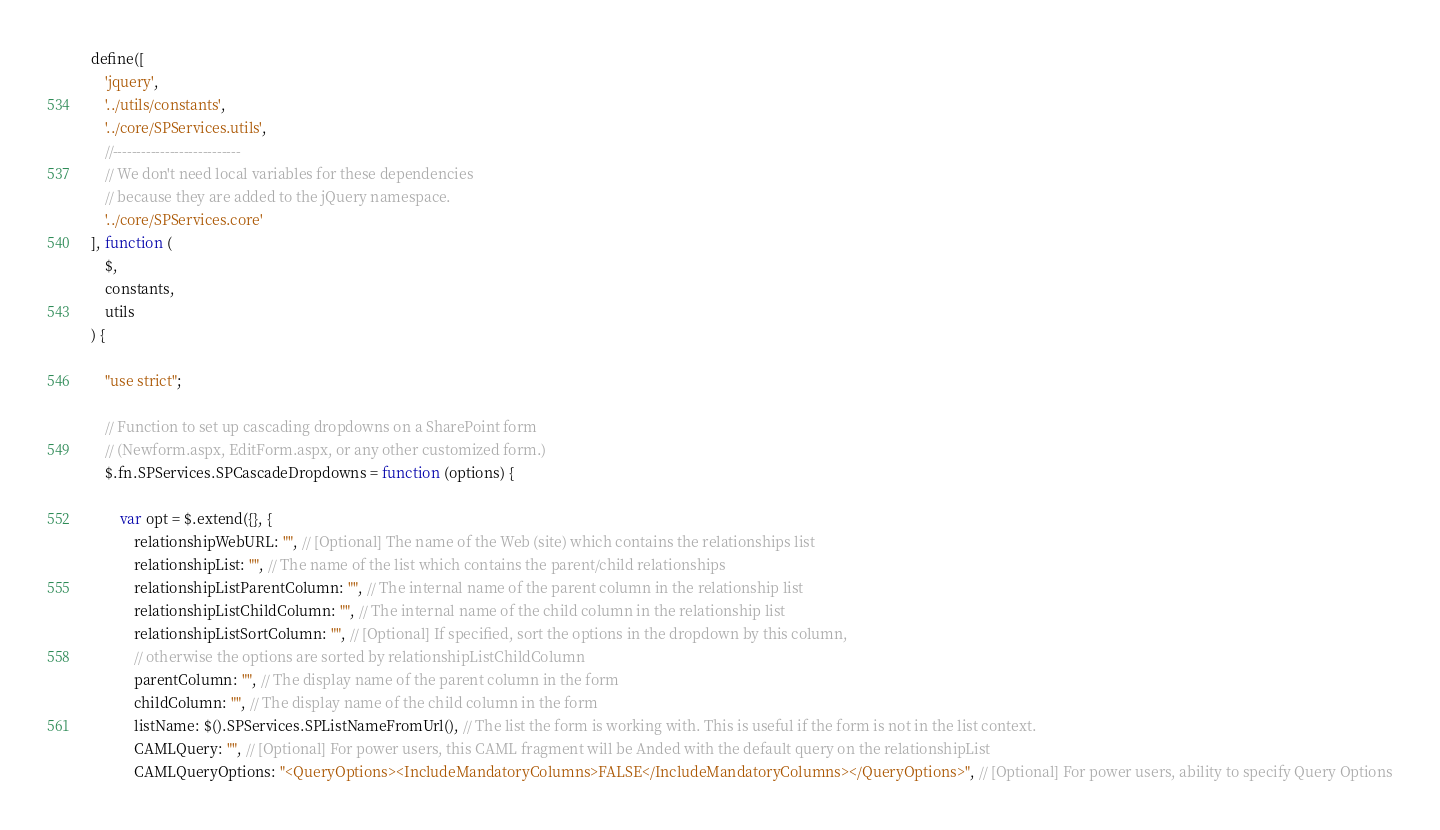<code> <loc_0><loc_0><loc_500><loc_500><_JavaScript_>define([
    'jquery',
    '../utils/constants',
    '../core/SPServices.utils',
    //---------------------------
    // We don't need local variables for these dependencies
    // because they are added to the jQuery namespace.
    '../core/SPServices.core'
], function (
    $,
    constants,
    utils
) {

    "use strict";

    // Function to set up cascading dropdowns on a SharePoint form
    // (Newform.aspx, EditForm.aspx, or any other customized form.)
    $.fn.SPServices.SPCascadeDropdowns = function (options) {

        var opt = $.extend({}, {
            relationshipWebURL: "", // [Optional] The name of the Web (site) which contains the relationships list
            relationshipList: "", // The name of the list which contains the parent/child relationships
            relationshipListParentColumn: "", // The internal name of the parent column in the relationship list
            relationshipListChildColumn: "", // The internal name of the child column in the relationship list
            relationshipListSortColumn: "", // [Optional] If specified, sort the options in the dropdown by this column,
            // otherwise the options are sorted by relationshipListChildColumn
            parentColumn: "", // The display name of the parent column in the form
            childColumn: "", // The display name of the child column in the form
            listName: $().SPServices.SPListNameFromUrl(), // The list the form is working with. This is useful if the form is not in the list context.
            CAMLQuery: "", // [Optional] For power users, this CAML fragment will be Anded with the default query on the relationshipList
            CAMLQueryOptions: "<QueryOptions><IncludeMandatoryColumns>FALSE</IncludeMandatoryColumns></QueryOptions>", // [Optional] For power users, ability to specify Query Options</code> 